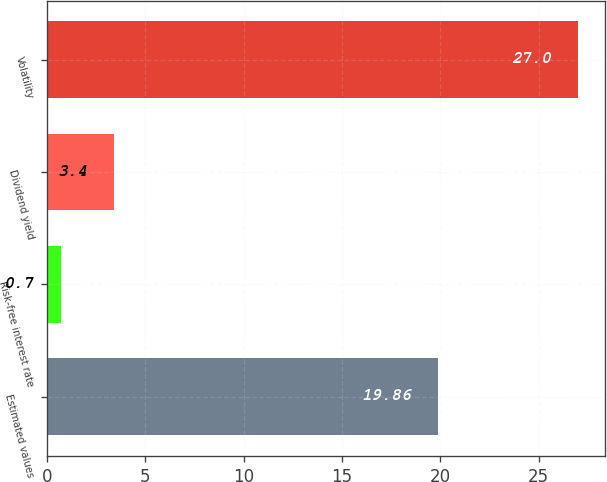<chart> <loc_0><loc_0><loc_500><loc_500><bar_chart><fcel>Estimated values<fcel>Risk-free interest rate<fcel>Dividend yield<fcel>Volatility<nl><fcel>19.86<fcel>0.7<fcel>3.4<fcel>27<nl></chart> 